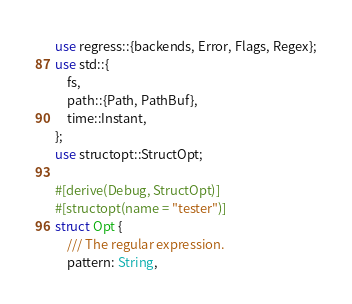<code> <loc_0><loc_0><loc_500><loc_500><_Rust_>use regress::{backends, Error, Flags, Regex};
use std::{
    fs,
    path::{Path, PathBuf},
    time::Instant,
};
use structopt::StructOpt;

#[derive(Debug, StructOpt)]
#[structopt(name = "tester")]
struct Opt {
    /// The regular expression.
    pattern: String,
</code> 